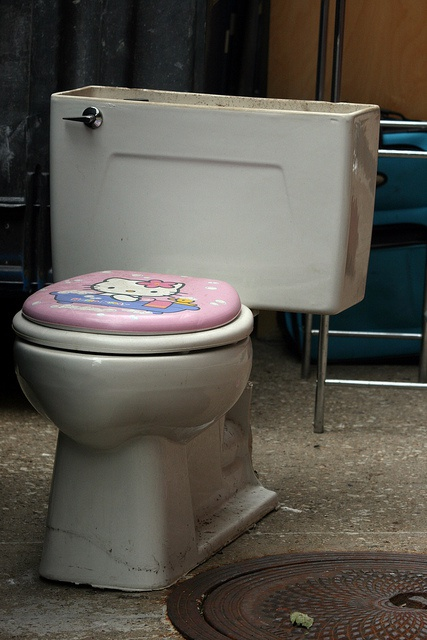Describe the objects in this image and their specific colors. I can see toilet in black and gray tones and chair in black, gray, and white tones in this image. 